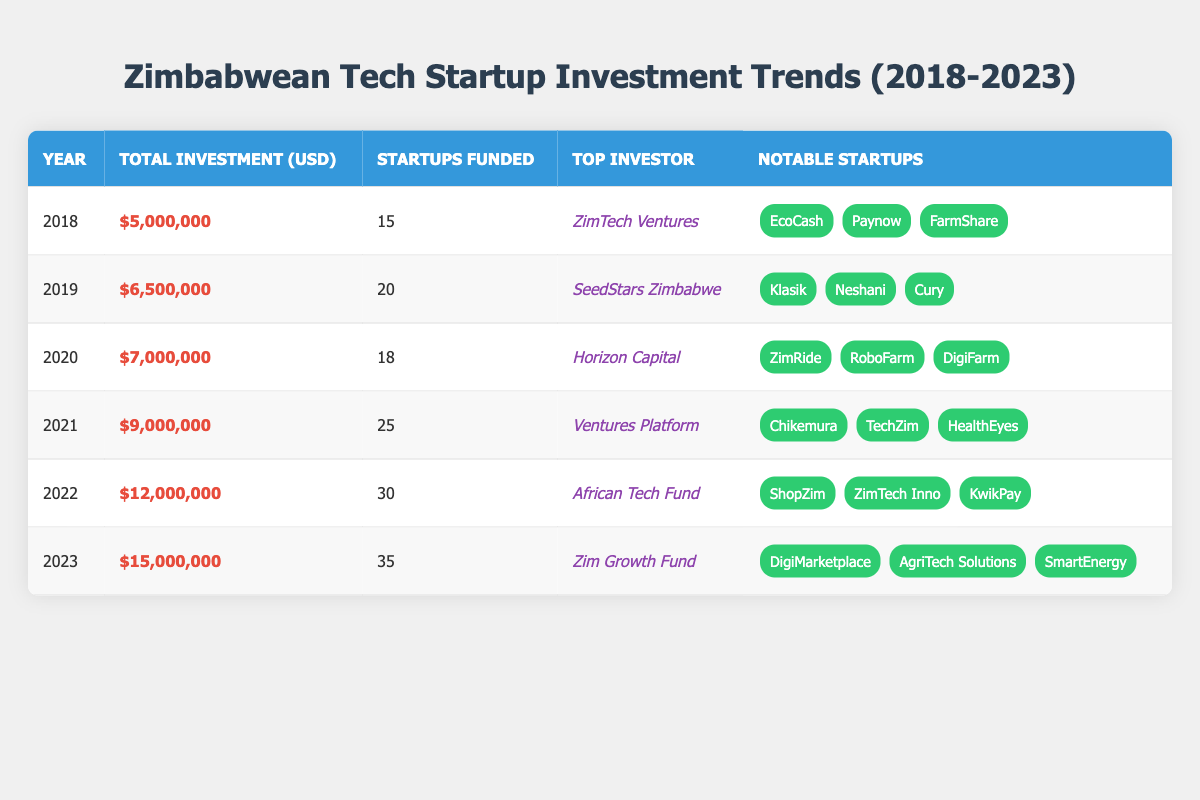What was the total investment in Zimbabwean tech startups in 2021? The table shows that the total investment in the year 2021 is listed as $9,000,000.
Answer: $9,000,000 Which year had the highest number of startups funded? By looking at the "Startups Funded" column, the year with the highest number is 2023 with 35 startups.
Answer: 2023 What was the average total investment from 2018 to 2023? To find the average, sum the total investments: 5000000 + 6500000 + 7000000 + 9000000 + 12000000 + 15000000 = 50000000. Then divide by the number of years (6): 50000000 / 6 = 8333333.33.
Answer: 8333333.33 Is ZimTech Ventures the top investor in 2019? The table indicates that the top investor in 2019 is SeedStars Zimbabwe, not ZimTech Ventures.
Answer: No What is the increase in total investment from 2022 to 2023? The total investment in 2022 is $12,000,000 and in 2023 it is $15,000,000. The difference is $15,000,000 - $12,000,000 = $3,000,000.
Answer: $3,000,000 Did the number of startups funded ever decrease from one year to the next between 2018 and 2023? Comparing the number of startups funded each year, there were 15 in 2018 and 20 in 2019, then 18 in 2020 (decrease). Hence, yes, there was a decrease.
Answer: Yes What was the total amount invested in tech startups over the years 2018 to 2020? Adding the total investments from 2018 to 2020 gives: 5000000 (2018) + 6500000 (2019) + 7000000 (2020) = 18500000.
Answer: 18500000 In which year did the amount invested cross $10,000,000 for the first time? Observing the total investment, it first crosses $10,000,000 in the year 2022, where it is $12,000,000.
Answer: 2022 What is the most notable startup listed for 2020? The most notable startup for 2020 according to the table is ZimRide.
Answer: ZimRide 